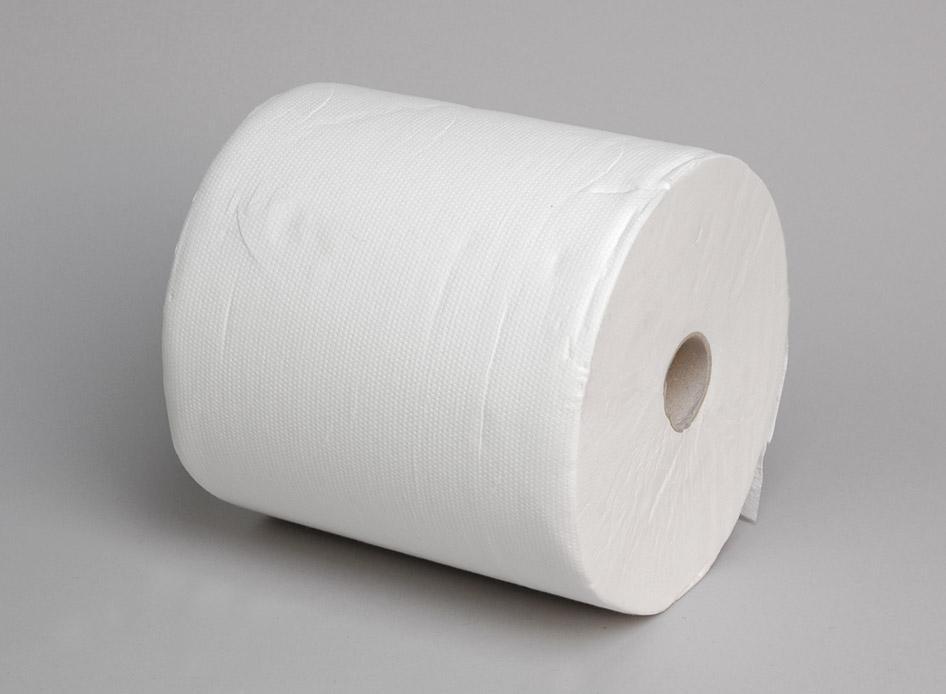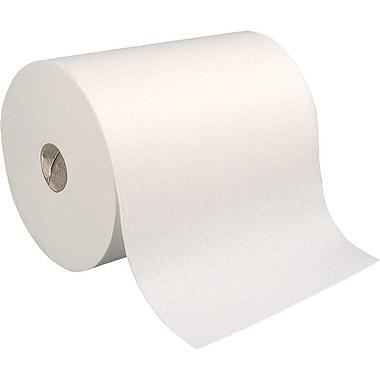The first image is the image on the left, the second image is the image on the right. Considering the images on both sides, is "there are at seven rolls total" valid? Answer yes or no. No. 